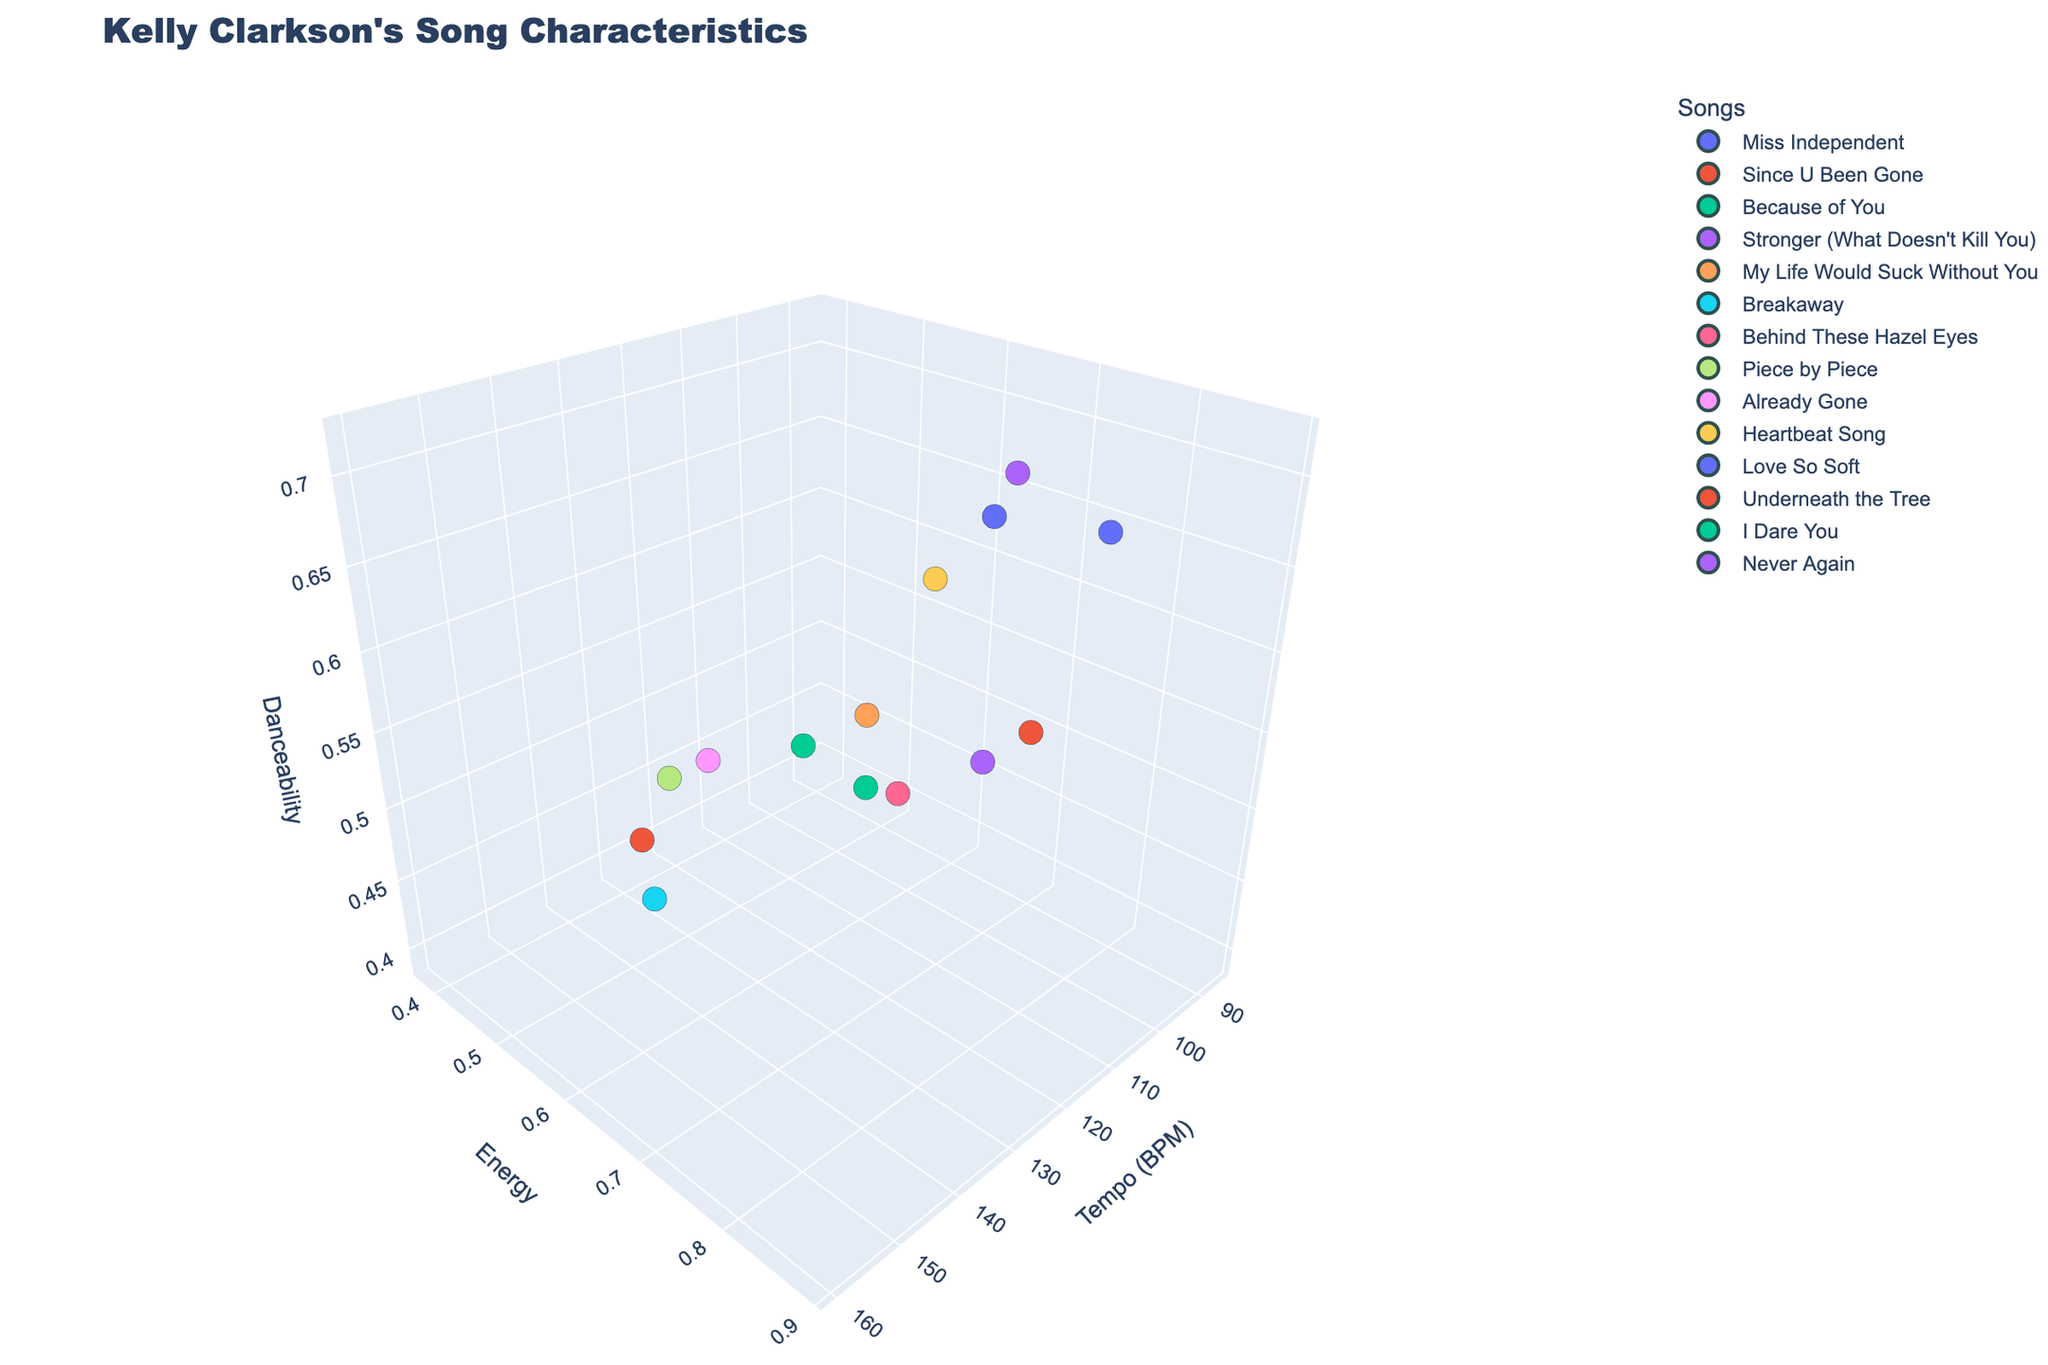What is the average tempo of all listed songs? To find the average tempo, sum the tempo of all listed songs and divide by the number of songs. The sum of the tempos is 1867 BPM, and there are 13 songs. So, the average is 1867/13 ≈ 143.62 BPM.
Answer: 143.62 BPM Which song has the highest energy? By observing the 'Energy' axis and identifying the maximum value, the highest energy value is 0.89, which corresponds to "Since U Been Gone."
Answer: "Since U Been Gone" Among all songs, which one has the lowest danceability? By looking at the 'Danceability' axis for the minimum value, the lowest danceability is 0.39, corresponding to "Because of You."
Answer: "Because of You" What is the title displayed on the figure? The title is usually found at the top of the figure. In this case, it reads "Kelly Clarkson's Song Characteristics."
Answer: "Kelly Clarkson's Song Characteristics" What is the range of the 'Tempo (BPM)' axis? To find the range of the Tempo axis, locate the minimum and maximum values on the axis. The minimum is 86 BPM (for "Because of You"), and the maximum is 160 BPM (for "Breakaway" and "Underneath the Tree").
Answer: 86 BPM to 160 BPM Which song has both high energy and high danceability? Look for data points in the upper-right region of the 'Energy' and 'Danceability' axes. "Stronger (What Doesn't Kill You)" and "Heartbeat Song" fall in this category with high values in both attributes.
Answer: "Stronger (What Doesn't Kill You)" and "Heartbeat Song" How many songs have a tempo of at least 132 BPM? Count the data points along the 'Tempo (BPM)' axis that are at or above 132 BPM. There are 6 songs: "Since U Been Gone," "Behind These Hazel Eyes," "Already Gone," "My Life Would Suck Without You," "Never Again," and "Heartbeat Song."
Answer: 6 songs Compare the danceability of "Miss Independent" and "Piece by Piece." Which is higher? Look at the 'Danceability' values for these two songs. "Miss Independent" has a danceability of 0.68, while "Piece by Piece" has 0.44.
Answer: "Miss Independent" Are there any songs that have the same tempo and energy? Check for data points that align with each other on both the 'Tempo' and 'Energy' axes. No songs have exactly the same combination of tempo and energy.
Answer: No What is the overall trend between tempo and danceability in Kelly's songs? Observe the entire scatter plot to see the relationship between tempo and danceability. As there is no clear linear correlation, it suggests that there is no strong trend between tempo and danceability across Kelly's songs.
Answer: No strong trend 